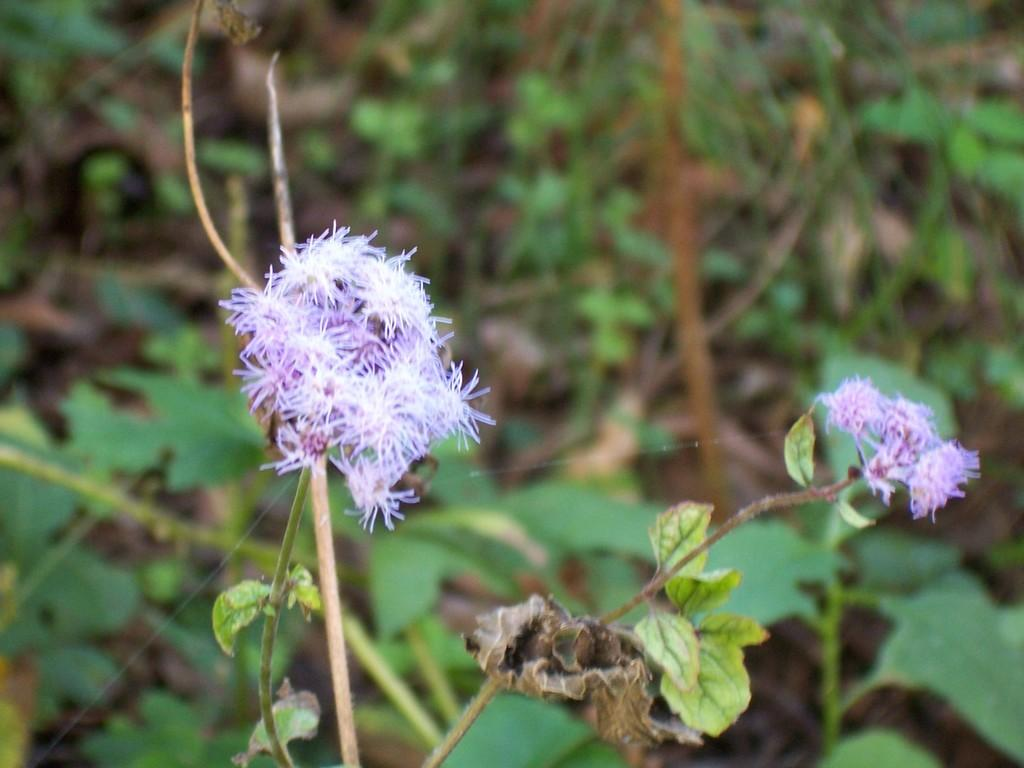What can be seen in the foreground of the picture? There are flowers, leaves, and stems in the foreground of the picture. Can you describe the type of plants in the foreground? The plants in the foreground consist of flowers, leaves, and stems. What is visible in the background of the picture? There is greenery in the background of the picture. What type of game is being played by the writer in the picture? There is no writer or game present in the picture; it features flowers, leaves, stems, and greenery. 